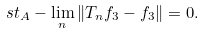<formula> <loc_0><loc_0><loc_500><loc_500>s t _ { A } - \lim _ { n } \left \| T _ { n } f _ { 3 } - f _ { 3 } \right \| = 0 .</formula> 